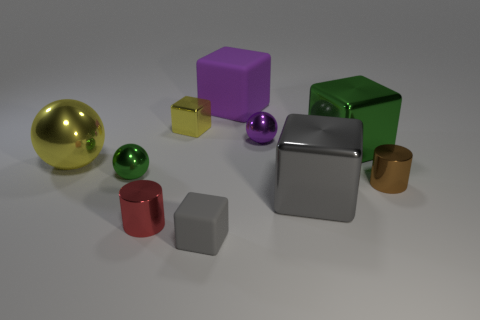Is there any sense of movement or dynamic action captured in the image? The image portrays a still life arrangement with no intrinsic movement; all objects are at rest. However, the positioning and orientation of the objects create a visual flow that guides the viewer's eyes across the scene. The absence of motion makes this a tranquil composition, allowing each form to be clearly observed and contemplated. 